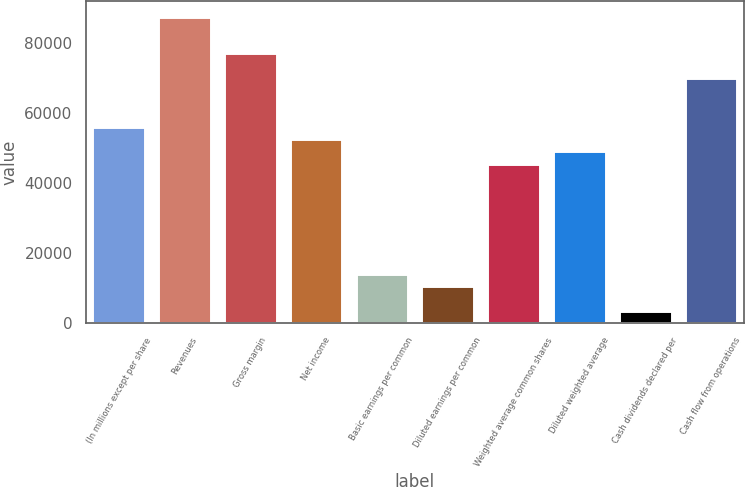Convert chart. <chart><loc_0><loc_0><loc_500><loc_500><bar_chart><fcel>(In millions except per share<fcel>Revenues<fcel>Gross margin<fcel>Net income<fcel>Basic earnings per common<fcel>Diluted earnings per common<fcel>Weighted average common shares<fcel>Diluted weighted average<fcel>Cash dividends declared per<fcel>Cash flow from operations<nl><fcel>56051<fcel>87579.6<fcel>77070<fcel>52547.8<fcel>14013<fcel>10509.8<fcel>45541.5<fcel>49044.7<fcel>3503.47<fcel>70063.7<nl></chart> 